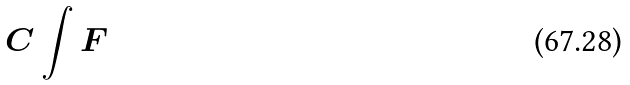Convert formula to latex. <formula><loc_0><loc_0><loc_500><loc_500>C \int F</formula> 